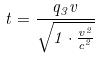<formula> <loc_0><loc_0><loc_500><loc_500>t = \frac { q _ { 3 } v } { \sqrt { 1 \cdot \frac { v ^ { 2 } } { c ^ { 2 } } } }</formula> 